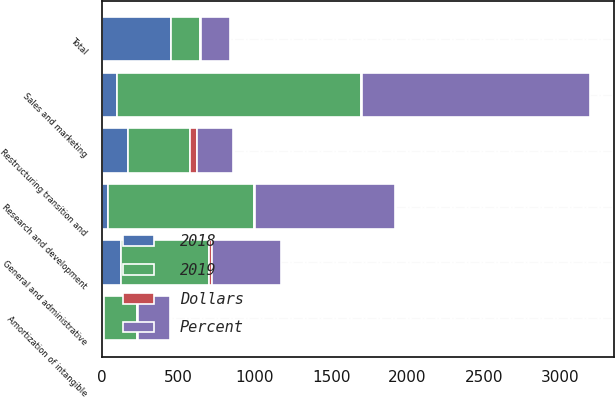Convert chart to OTSL. <chart><loc_0><loc_0><loc_500><loc_500><stacked_bar_chart><ecel><fcel>Sales and marketing<fcel>Research and development<fcel>General and administrative<fcel>Amortization of intangible<fcel>Restructuring transition and<fcel>Total<nl><fcel>Percent<fcel>1493<fcel>913<fcel>447<fcel>207<fcel>241<fcel>188<nl><fcel>2019<fcel>1593<fcel>956<fcel>574<fcel>220<fcel>410<fcel>188<nl><fcel>2018<fcel>100<fcel>43<fcel>127<fcel>13<fcel>169<fcel>452<nl><fcel>Dollars<fcel>6<fcel>4<fcel>22<fcel>6<fcel>41<fcel>12<nl></chart> 